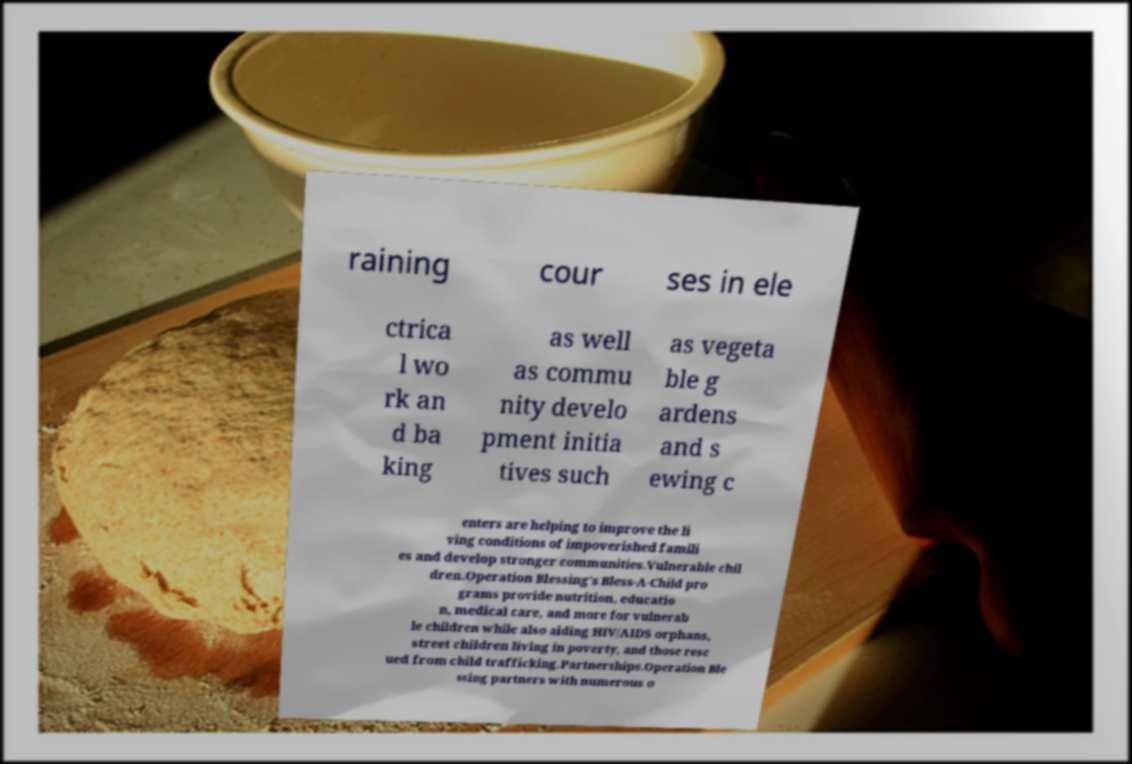Can you accurately transcribe the text from the provided image for me? raining cour ses in ele ctrica l wo rk an d ba king as well as commu nity develo pment initia tives such as vegeta ble g ardens and s ewing c enters are helping to improve the li ving conditions of impoverished famili es and develop stronger communities.Vulnerable chil dren.Operation Blessing's Bless-A-Child pro grams provide nutrition, educatio n, medical care, and more for vulnerab le children while also aiding HIV/AIDS orphans, street children living in poverty, and those resc ued from child trafficking.Partnerships.Operation Ble ssing partners with numerous o 